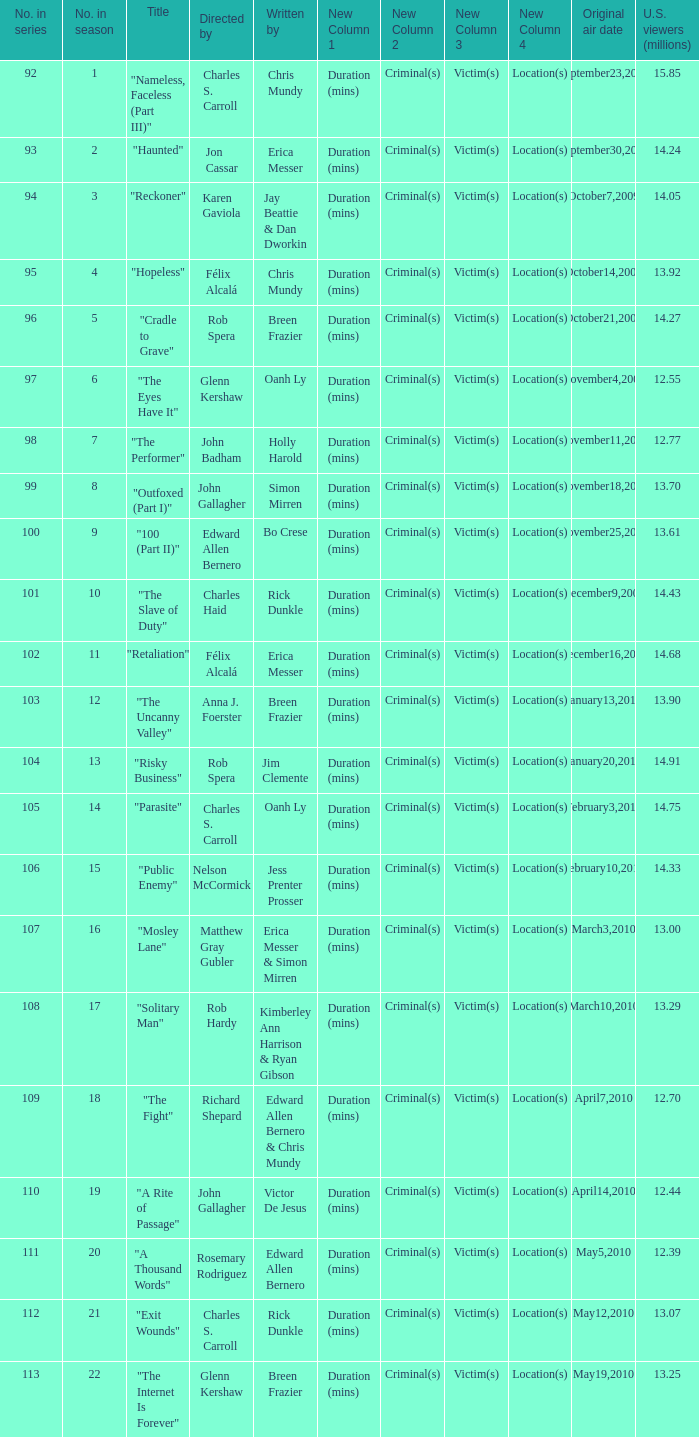What was the first episode in the season directed by nelson mccormick? 15.0. 